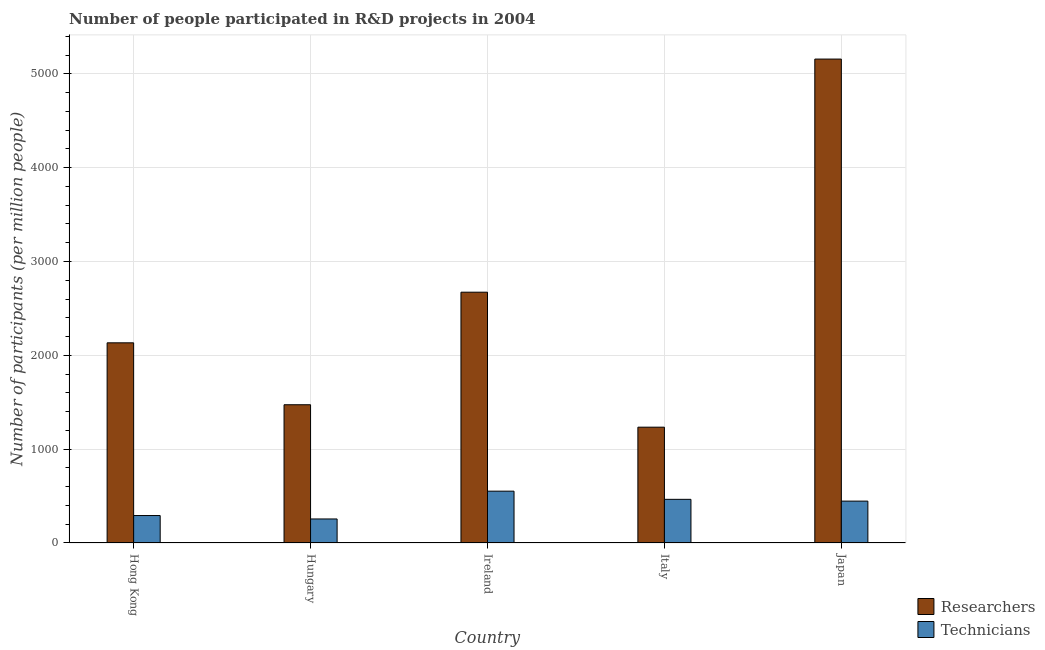Are the number of bars per tick equal to the number of legend labels?
Give a very brief answer. Yes. Are the number of bars on each tick of the X-axis equal?
Offer a terse response. Yes. How many bars are there on the 2nd tick from the left?
Offer a very short reply. 2. In how many cases, is the number of bars for a given country not equal to the number of legend labels?
Make the answer very short. 0. What is the number of technicians in Italy?
Keep it short and to the point. 465.22. Across all countries, what is the maximum number of technicians?
Offer a very short reply. 552.33. Across all countries, what is the minimum number of technicians?
Provide a short and direct response. 256.04. In which country was the number of technicians maximum?
Your answer should be very brief. Ireland. In which country was the number of technicians minimum?
Provide a short and direct response. Hungary. What is the total number of researchers in the graph?
Provide a succinct answer. 1.27e+04. What is the difference between the number of researchers in Hong Kong and that in Japan?
Make the answer very short. -3023.73. What is the difference between the number of technicians in Hong Kong and the number of researchers in Ireland?
Offer a very short reply. -2380.04. What is the average number of technicians per country?
Give a very brief answer. 402.45. What is the difference between the number of technicians and number of researchers in Italy?
Make the answer very short. -768.96. In how many countries, is the number of researchers greater than 1800 ?
Offer a very short reply. 3. What is the ratio of the number of researchers in Ireland to that in Japan?
Offer a very short reply. 0.52. What is the difference between the highest and the second highest number of technicians?
Your response must be concise. 87.11. What is the difference between the highest and the lowest number of researchers?
Give a very brief answer. 3922.65. In how many countries, is the number of researchers greater than the average number of researchers taken over all countries?
Provide a succinct answer. 2. What does the 1st bar from the left in Ireland represents?
Give a very brief answer. Researchers. What does the 1st bar from the right in Hong Kong represents?
Offer a very short reply. Technicians. How many bars are there?
Offer a terse response. 10. Are all the bars in the graph horizontal?
Provide a succinct answer. No. What is the difference between two consecutive major ticks on the Y-axis?
Your answer should be compact. 1000. Are the values on the major ticks of Y-axis written in scientific E-notation?
Provide a short and direct response. No. Does the graph contain any zero values?
Your answer should be very brief. No. Does the graph contain grids?
Offer a very short reply. Yes. How many legend labels are there?
Provide a short and direct response. 2. How are the legend labels stacked?
Give a very brief answer. Vertical. What is the title of the graph?
Offer a terse response. Number of people participated in R&D projects in 2004. What is the label or title of the Y-axis?
Give a very brief answer. Number of participants (per million people). What is the Number of participants (per million people) in Researchers in Hong Kong?
Your response must be concise. 2133.09. What is the Number of participants (per million people) of Technicians in Hong Kong?
Give a very brief answer. 292.44. What is the Number of participants (per million people) in Researchers in Hungary?
Make the answer very short. 1473.13. What is the Number of participants (per million people) of Technicians in Hungary?
Offer a terse response. 256.04. What is the Number of participants (per million people) of Researchers in Ireland?
Make the answer very short. 2672.48. What is the Number of participants (per million people) of Technicians in Ireland?
Give a very brief answer. 552.33. What is the Number of participants (per million people) of Researchers in Italy?
Your answer should be very brief. 1234.18. What is the Number of participants (per million people) of Technicians in Italy?
Keep it short and to the point. 465.22. What is the Number of participants (per million people) in Researchers in Japan?
Provide a short and direct response. 5156.83. What is the Number of participants (per million people) in Technicians in Japan?
Offer a very short reply. 446.21. Across all countries, what is the maximum Number of participants (per million people) of Researchers?
Your answer should be very brief. 5156.83. Across all countries, what is the maximum Number of participants (per million people) in Technicians?
Keep it short and to the point. 552.33. Across all countries, what is the minimum Number of participants (per million people) of Researchers?
Make the answer very short. 1234.18. Across all countries, what is the minimum Number of participants (per million people) in Technicians?
Give a very brief answer. 256.04. What is the total Number of participants (per million people) in Researchers in the graph?
Provide a succinct answer. 1.27e+04. What is the total Number of participants (per million people) of Technicians in the graph?
Your answer should be very brief. 2012.25. What is the difference between the Number of participants (per million people) in Researchers in Hong Kong and that in Hungary?
Your response must be concise. 659.96. What is the difference between the Number of participants (per million people) of Technicians in Hong Kong and that in Hungary?
Ensure brevity in your answer.  36.4. What is the difference between the Number of participants (per million people) of Researchers in Hong Kong and that in Ireland?
Keep it short and to the point. -539.38. What is the difference between the Number of participants (per million people) of Technicians in Hong Kong and that in Ireland?
Your answer should be compact. -259.89. What is the difference between the Number of participants (per million people) of Researchers in Hong Kong and that in Italy?
Keep it short and to the point. 898.92. What is the difference between the Number of participants (per million people) in Technicians in Hong Kong and that in Italy?
Your response must be concise. -172.78. What is the difference between the Number of participants (per million people) in Researchers in Hong Kong and that in Japan?
Your answer should be compact. -3023.73. What is the difference between the Number of participants (per million people) of Technicians in Hong Kong and that in Japan?
Your answer should be compact. -153.77. What is the difference between the Number of participants (per million people) of Researchers in Hungary and that in Ireland?
Give a very brief answer. -1199.34. What is the difference between the Number of participants (per million people) of Technicians in Hungary and that in Ireland?
Provide a succinct answer. -296.29. What is the difference between the Number of participants (per million people) of Researchers in Hungary and that in Italy?
Give a very brief answer. 238.96. What is the difference between the Number of participants (per million people) in Technicians in Hungary and that in Italy?
Give a very brief answer. -209.17. What is the difference between the Number of participants (per million people) of Researchers in Hungary and that in Japan?
Give a very brief answer. -3683.7. What is the difference between the Number of participants (per million people) in Technicians in Hungary and that in Japan?
Make the answer very short. -190.17. What is the difference between the Number of participants (per million people) in Researchers in Ireland and that in Italy?
Your response must be concise. 1438.3. What is the difference between the Number of participants (per million people) in Technicians in Ireland and that in Italy?
Your response must be concise. 87.11. What is the difference between the Number of participants (per million people) of Researchers in Ireland and that in Japan?
Your answer should be very brief. -2484.35. What is the difference between the Number of participants (per million people) in Technicians in Ireland and that in Japan?
Give a very brief answer. 106.12. What is the difference between the Number of participants (per million people) in Researchers in Italy and that in Japan?
Your response must be concise. -3922.65. What is the difference between the Number of participants (per million people) in Technicians in Italy and that in Japan?
Your answer should be compact. 19.01. What is the difference between the Number of participants (per million people) in Researchers in Hong Kong and the Number of participants (per million people) in Technicians in Hungary?
Offer a very short reply. 1877.05. What is the difference between the Number of participants (per million people) of Researchers in Hong Kong and the Number of participants (per million people) of Technicians in Ireland?
Your answer should be very brief. 1580.76. What is the difference between the Number of participants (per million people) of Researchers in Hong Kong and the Number of participants (per million people) of Technicians in Italy?
Keep it short and to the point. 1667.88. What is the difference between the Number of participants (per million people) in Researchers in Hong Kong and the Number of participants (per million people) in Technicians in Japan?
Give a very brief answer. 1686.88. What is the difference between the Number of participants (per million people) in Researchers in Hungary and the Number of participants (per million people) in Technicians in Ireland?
Your answer should be compact. 920.8. What is the difference between the Number of participants (per million people) of Researchers in Hungary and the Number of participants (per million people) of Technicians in Italy?
Offer a very short reply. 1007.91. What is the difference between the Number of participants (per million people) of Researchers in Hungary and the Number of participants (per million people) of Technicians in Japan?
Give a very brief answer. 1026.92. What is the difference between the Number of participants (per million people) of Researchers in Ireland and the Number of participants (per million people) of Technicians in Italy?
Provide a short and direct response. 2207.26. What is the difference between the Number of participants (per million people) of Researchers in Ireland and the Number of participants (per million people) of Technicians in Japan?
Offer a terse response. 2226.27. What is the difference between the Number of participants (per million people) in Researchers in Italy and the Number of participants (per million people) in Technicians in Japan?
Make the answer very short. 787.97. What is the average Number of participants (per million people) of Researchers per country?
Give a very brief answer. 2533.94. What is the average Number of participants (per million people) of Technicians per country?
Your answer should be compact. 402.45. What is the difference between the Number of participants (per million people) in Researchers and Number of participants (per million people) in Technicians in Hong Kong?
Your answer should be compact. 1840.65. What is the difference between the Number of participants (per million people) of Researchers and Number of participants (per million people) of Technicians in Hungary?
Offer a very short reply. 1217.09. What is the difference between the Number of participants (per million people) of Researchers and Number of participants (per million people) of Technicians in Ireland?
Your answer should be very brief. 2120.15. What is the difference between the Number of participants (per million people) of Researchers and Number of participants (per million people) of Technicians in Italy?
Your response must be concise. 768.96. What is the difference between the Number of participants (per million people) of Researchers and Number of participants (per million people) of Technicians in Japan?
Provide a succinct answer. 4710.62. What is the ratio of the Number of participants (per million people) of Researchers in Hong Kong to that in Hungary?
Keep it short and to the point. 1.45. What is the ratio of the Number of participants (per million people) of Technicians in Hong Kong to that in Hungary?
Your answer should be compact. 1.14. What is the ratio of the Number of participants (per million people) of Researchers in Hong Kong to that in Ireland?
Your answer should be compact. 0.8. What is the ratio of the Number of participants (per million people) in Technicians in Hong Kong to that in Ireland?
Offer a terse response. 0.53. What is the ratio of the Number of participants (per million people) in Researchers in Hong Kong to that in Italy?
Your answer should be compact. 1.73. What is the ratio of the Number of participants (per million people) of Technicians in Hong Kong to that in Italy?
Give a very brief answer. 0.63. What is the ratio of the Number of participants (per million people) of Researchers in Hong Kong to that in Japan?
Offer a very short reply. 0.41. What is the ratio of the Number of participants (per million people) in Technicians in Hong Kong to that in Japan?
Your response must be concise. 0.66. What is the ratio of the Number of participants (per million people) in Researchers in Hungary to that in Ireland?
Your answer should be compact. 0.55. What is the ratio of the Number of participants (per million people) of Technicians in Hungary to that in Ireland?
Make the answer very short. 0.46. What is the ratio of the Number of participants (per million people) in Researchers in Hungary to that in Italy?
Offer a very short reply. 1.19. What is the ratio of the Number of participants (per million people) of Technicians in Hungary to that in Italy?
Give a very brief answer. 0.55. What is the ratio of the Number of participants (per million people) in Researchers in Hungary to that in Japan?
Give a very brief answer. 0.29. What is the ratio of the Number of participants (per million people) in Technicians in Hungary to that in Japan?
Offer a very short reply. 0.57. What is the ratio of the Number of participants (per million people) in Researchers in Ireland to that in Italy?
Provide a short and direct response. 2.17. What is the ratio of the Number of participants (per million people) in Technicians in Ireland to that in Italy?
Your answer should be compact. 1.19. What is the ratio of the Number of participants (per million people) of Researchers in Ireland to that in Japan?
Ensure brevity in your answer.  0.52. What is the ratio of the Number of participants (per million people) in Technicians in Ireland to that in Japan?
Provide a short and direct response. 1.24. What is the ratio of the Number of participants (per million people) in Researchers in Italy to that in Japan?
Your response must be concise. 0.24. What is the ratio of the Number of participants (per million people) of Technicians in Italy to that in Japan?
Offer a very short reply. 1.04. What is the difference between the highest and the second highest Number of participants (per million people) of Researchers?
Your answer should be very brief. 2484.35. What is the difference between the highest and the second highest Number of participants (per million people) of Technicians?
Provide a short and direct response. 87.11. What is the difference between the highest and the lowest Number of participants (per million people) of Researchers?
Give a very brief answer. 3922.65. What is the difference between the highest and the lowest Number of participants (per million people) of Technicians?
Offer a terse response. 296.29. 